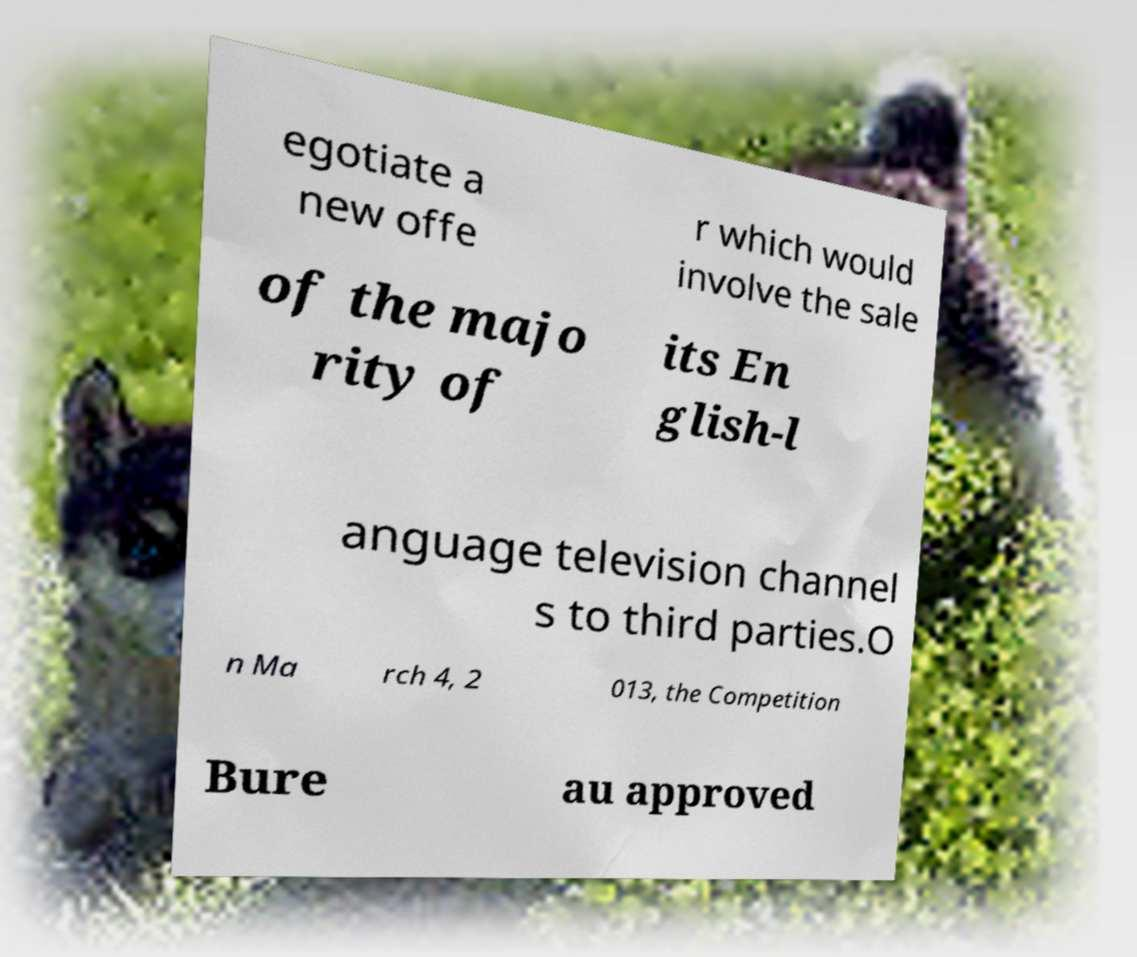Can you read and provide the text displayed in the image?This photo seems to have some interesting text. Can you extract and type it out for me? egotiate a new offe r which would involve the sale of the majo rity of its En glish-l anguage television channel s to third parties.O n Ma rch 4, 2 013, the Competition Bure au approved 